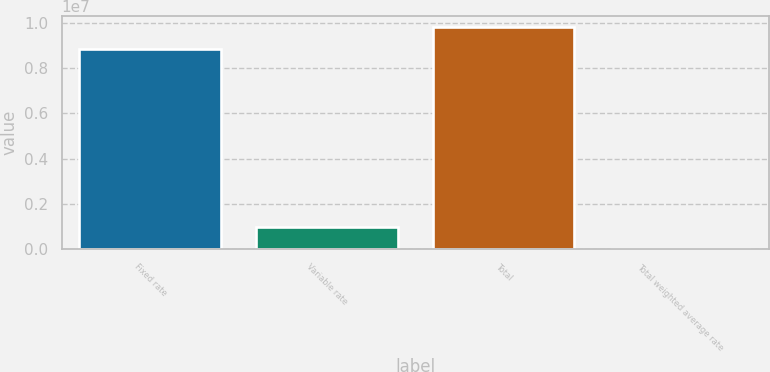<chart> <loc_0><loc_0><loc_500><loc_500><bar_chart><fcel>Fixed rate<fcel>Variable rate<fcel>Total<fcel>Total weighted average rate<nl><fcel>8.84168e+06<fcel>968873<fcel>9.81054e+06<fcel>4.71<nl></chart> 